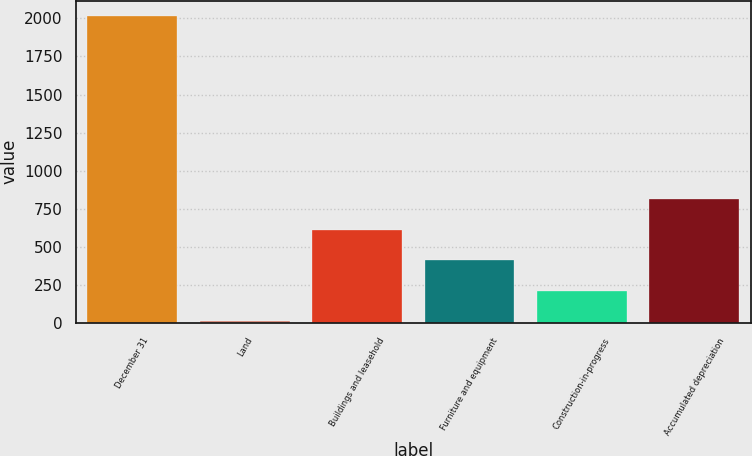Convert chart. <chart><loc_0><loc_0><loc_500><loc_500><bar_chart><fcel>December 31<fcel>Land<fcel>Buildings and leasehold<fcel>Furniture and equipment<fcel>Construction-in-progress<fcel>Accumulated depreciation<nl><fcel>2016<fcel>12<fcel>613.2<fcel>412.8<fcel>212.4<fcel>813.6<nl></chart> 